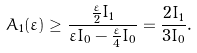<formula> <loc_0><loc_0><loc_500><loc_500>A _ { 1 } ( \varepsilon ) \geq \frac { \frac { \varepsilon } { 2 } I _ { 1 } } { \varepsilon I _ { 0 } - \frac { \varepsilon } { 4 } I _ { 0 } } = \frac { 2 I _ { 1 } } { 3 I _ { 0 } } .</formula> 